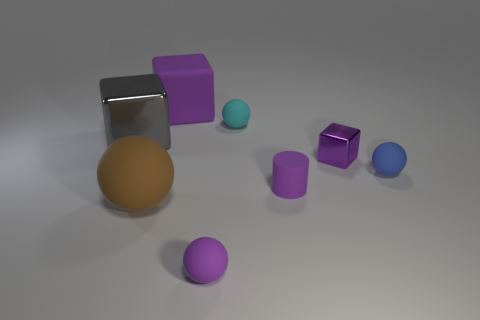What number of small purple things are the same shape as the big gray metallic thing?
Provide a succinct answer. 1. There is a ball that is the same color as the cylinder; what material is it?
Make the answer very short. Rubber. There is a purple rubber cylinder right of the matte sphere that is behind the tiny blue sphere; what number of brown spheres are left of it?
Your answer should be compact. 1. Is there a small red ball that has the same material as the purple cylinder?
Offer a terse response. No. The matte sphere that is the same color as the tiny rubber cylinder is what size?
Keep it short and to the point. Small. Are there fewer small red shiny cylinders than small metallic things?
Ensure brevity in your answer.  Yes. Is the color of the big object that is behind the large gray block the same as the big metal block?
Offer a terse response. No. The tiny thing on the left side of the tiny matte sphere behind the block right of the tiny cylinder is made of what material?
Offer a very short reply. Rubber. Is there another rubber block that has the same color as the matte cube?
Your answer should be very brief. No. Is the number of small purple spheres that are behind the cyan thing less than the number of large gray cubes?
Keep it short and to the point. Yes. 